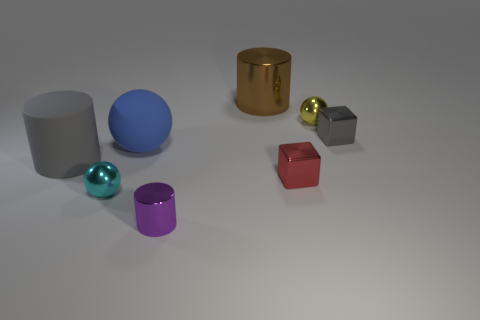What can you infer about the texture of the surface on which the objects are placed? The surface appears to be smooth with some specular highlights reflecting off it, suggesting that it's likely a polished or matte material, providing a neutral backdrop for the objects. 